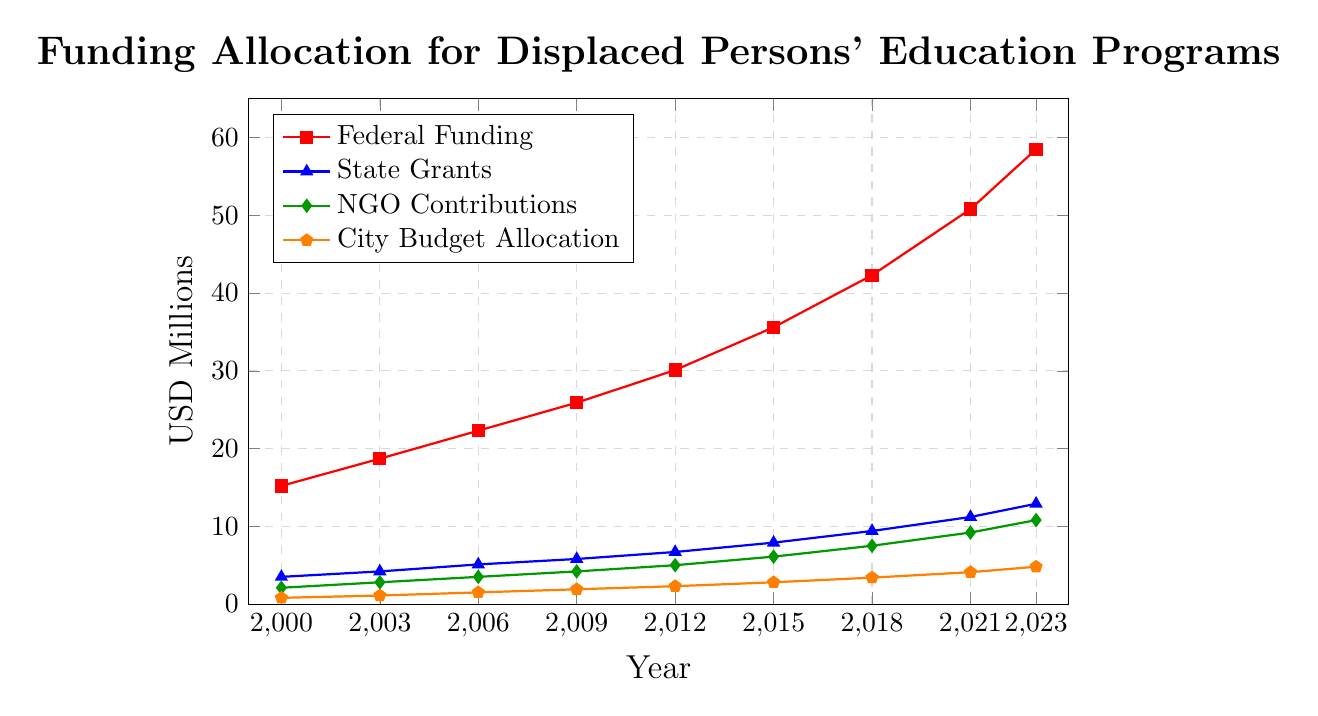What was the total funding allocation for displaced persons' education programs in 2023? To find the total funding allocation in 2023, sum up all the different sources of funding for that year: Federal (58.5), State Grants (12.9), NGO Contributions (10.8), and City Budget Allocation (4.8). The total is 58.5 + 12.9 + 10.8 + 4.8 = 87.0
Answer: 87.0 How did Federal Funding compare to NGO Contributions in 2021? Look at the figures for Federal Funding and NGO Contributions in 2021. Federal Funding was 50.8, while NGO Contributions were 9.2. Clearly, Federal Funding was much higher than NGO Contributions in 2021.
Answer: Federal Funding was higher What's the average annual increase in State Grants from 2000 to 2023? First, calculate the total increase in State Grants from 2000 to 2023: 12.9 - 3.5 = 9.4. Then, determine the number of years: 2023 - 2000 = 23 years. The average annual increase is 9.4 / 23 ≈ 0.41.
Answer: 0.41 Which funding source showed the most significant growth from 2000 to 2023? Calculate the increase for each funding source from 2000 to 2023: Federal (58.5 - 15.2 = 43.3), State Grants (12.9 - 3.5 = 9.4), NGO Contributions (10.8 - 2.1 = 8.7), City Budget Allocation (4.8 - 0.8 = 4.0). Federal Funding showed the most significant growth at 43.3.
Answer: Federal Funding In what year did City Budget Allocation first reach 2 USD million? Look for the first year where City Budget Allocation was equal to or greater than 2 USD million. According to the data, this happened in 2012, where it was 2.3 million.
Answer: 2012 What is the relative growth rate of Federal Funding between 2015 and 2023? First, calculate the Federal Funding in 2015 and 2023: 35.6 and 58.5 respectively. The growth is 58.5 - 35.6 = 22.9. The relative growth rate is (22.9 / 35.6) * 100 ≈ 64.3%.
Answer: 64.3% Which funding source reached double digits first, and in what year? Identify the year when each funding source first reached 10 million: Federal Funding in 2009 (25.9), State Grants in 2021 (11.2), NGO Contributions in 2021 (9.2, not 10 yet), City Budget Allocation does not reach 10 million by 2023. Therefore, Federal Funding first reached double digits in 2009.
Answer: Federal Funding in 2009 Compare the funding from NGOs and the City Budget in 2006. Which was higher and by how much? Look at the values for NGO Contributions (3.5) and City Budget Allocation (1.5) in 2006. Calculate the difference: 3.5 - 1.5 = 2.0. NGO Contributions were higher by 2.0 million USD.
Answer: NGOs by 2.0 What is the trend in NGO Contributions from 2000 to 2023? Observe the values of NGO Contributions from 2000 (2.1) to 2023 (10.8). It has been increasing consistently, indicating a positive and growing trend.
Answer: Increasing consistently Calculate the average funding allocation for City Budget Allocation from 2000 to 2023. Sum the values for City Budget Allocation from 2000 to 2023: 0.8 + 1.1 + 1.5 + 1.9 + 2.3 + 2.8 + 3.4 + 4.1 + 4.8 = 22.7. There are 9 data points, so the average is 22.7 / 9 ≈ 2.52.
Answer: 2.52 